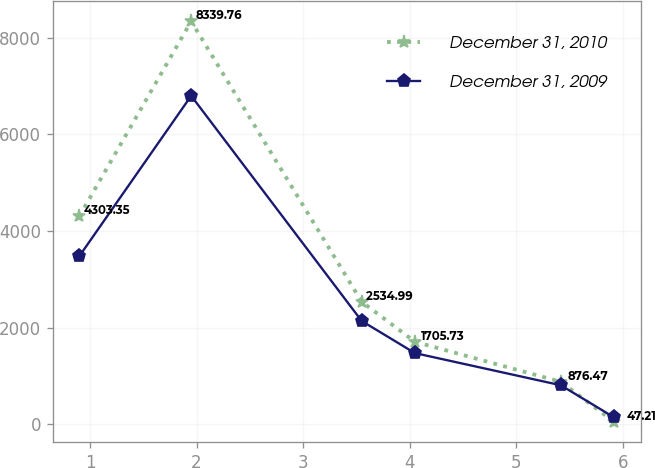<chart> <loc_0><loc_0><loc_500><loc_500><line_chart><ecel><fcel>December 31, 2010<fcel>December 31, 2009<nl><fcel>0.9<fcel>4303.35<fcel>3477.85<nl><fcel>1.95<fcel>8339.76<fcel>6797.94<nl><fcel>3.55<fcel>2534.99<fcel>2137.34<nl><fcel>4.05<fcel>1705.73<fcel>1471.54<nl><fcel>5.42<fcel>876.47<fcel>805.74<nl><fcel>5.92<fcel>47.21<fcel>139.94<nl></chart> 